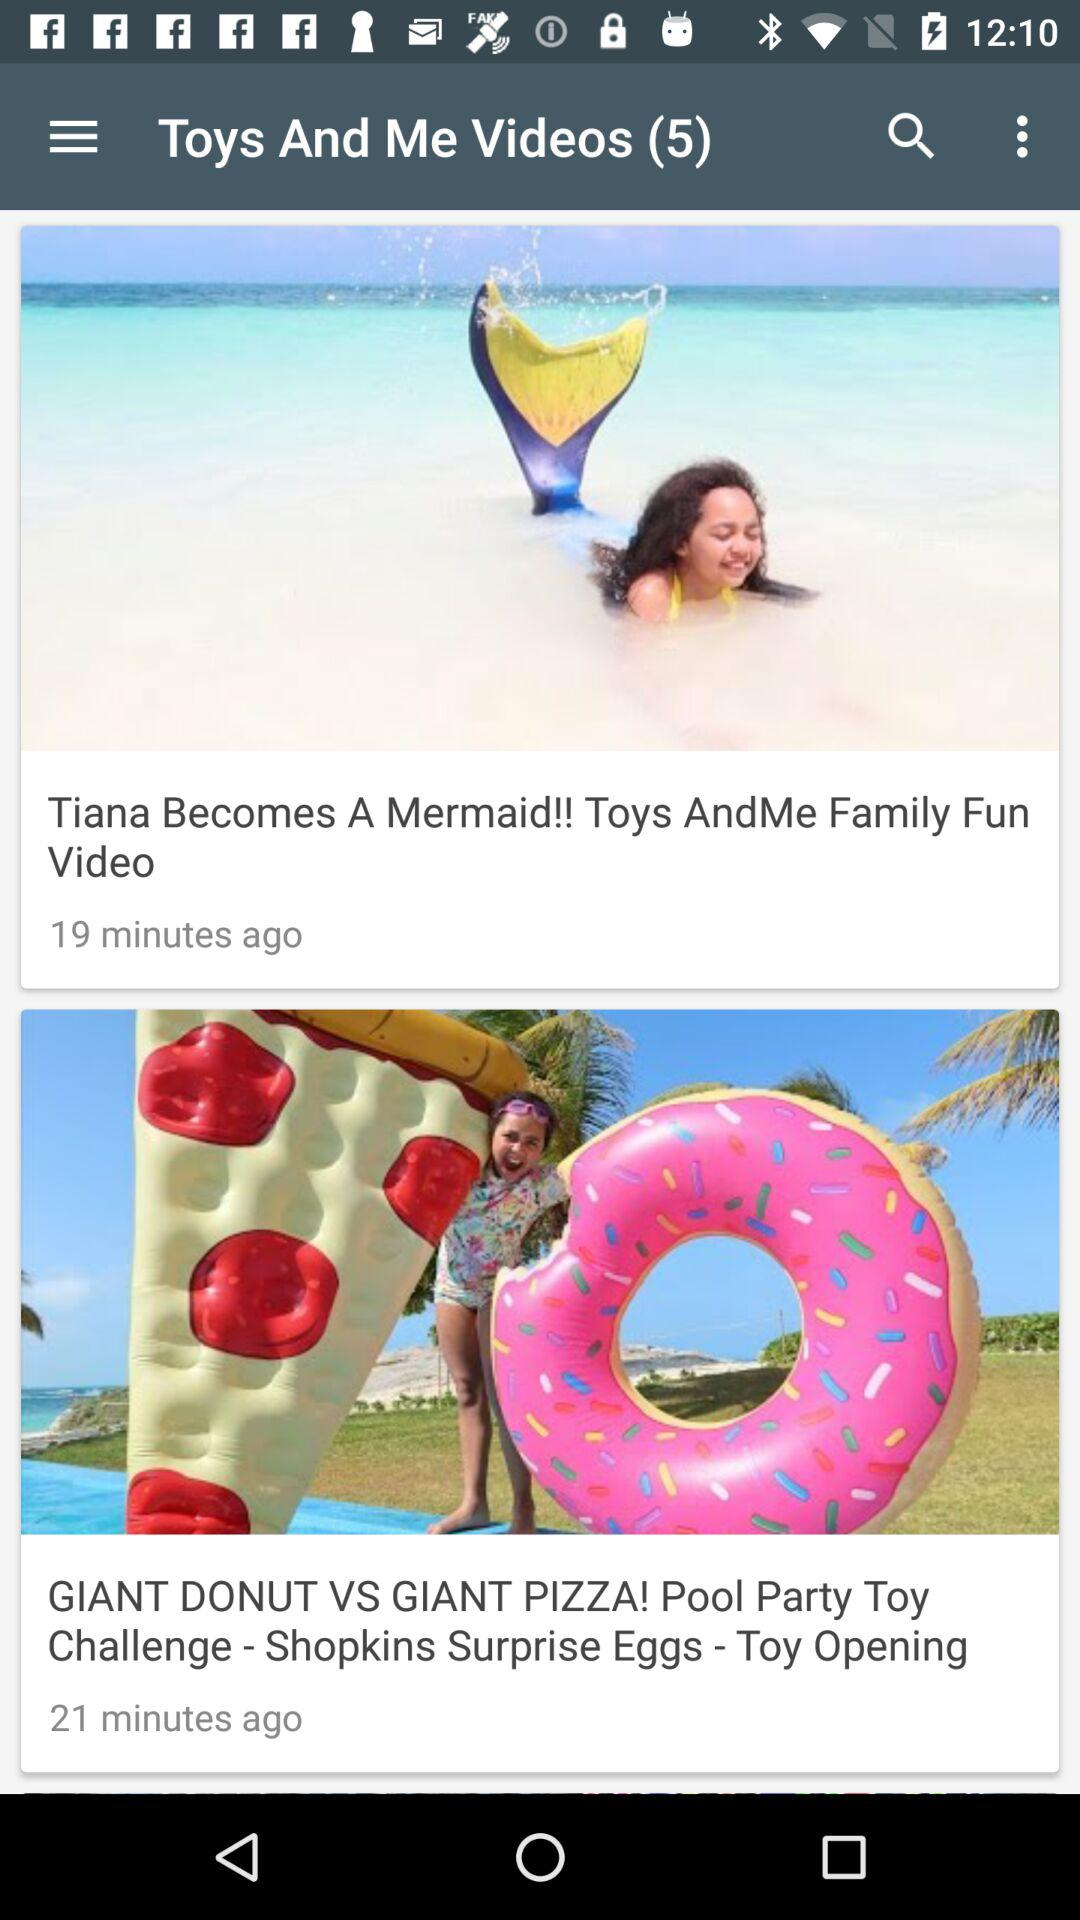At what time was the "GIANT DONUT VS GIANT PIZZA" video uploaded? The "GIANT DONUT VS GIANT PIZZA" video was uploaded 21 minutes ago. 